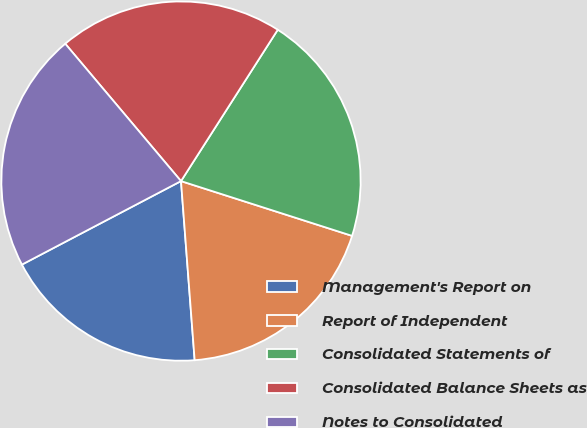Convert chart. <chart><loc_0><loc_0><loc_500><loc_500><pie_chart><fcel>Management's Report on<fcel>Report of Independent<fcel>Consolidated Statements of<fcel>Consolidated Balance Sheets as<fcel>Notes to Consolidated<nl><fcel>18.52%<fcel>18.86%<fcel>20.88%<fcel>20.2%<fcel>21.55%<nl></chart> 